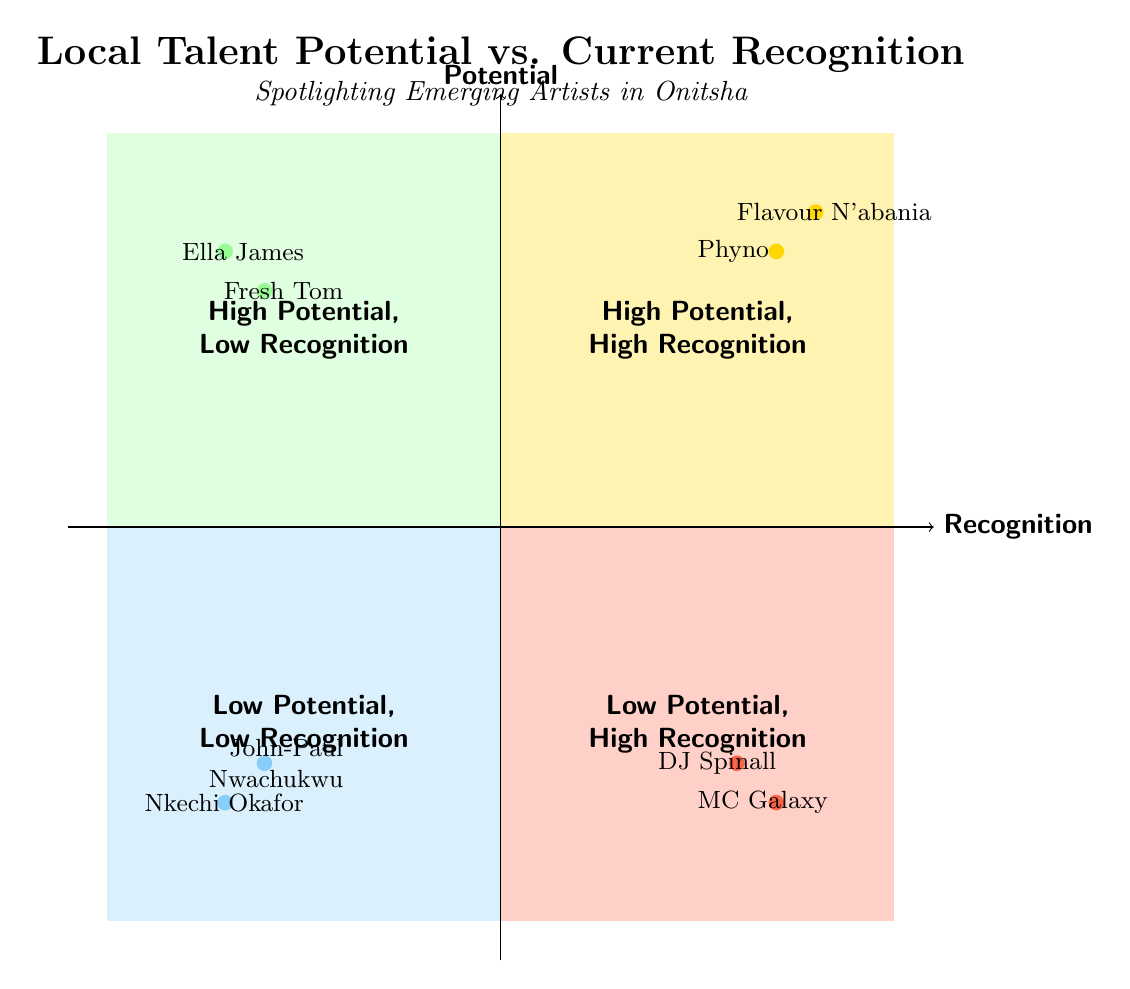What are the names of the artists in the High Potential, High Recognition quadrant? In the diagram, the High Potential, High Recognition quadrant lists the names of two artists: Flavour N'abania and Phyno. These names are located in the top right quadrant, which signifies both high potential and high recognition.
Answer: Flavour N'abania, Phyno How many artists are listed in the Low Potential, Low Recognition quadrant? The Low Potential, Low Recognition quadrant contains two artists: John-Paul Nwachukwu and Nkechi Okafor. By counting the elements in this quadrant, we find there are a total of two artists.
Answer: 2 Which artist is recognized within church circles in the High Potential, Low Recognition quadrant? In the High Potential, Low Recognition quadrant, Ella James is described as a talented gospel singer currently recognized within church circles. This information is found in the upper left quadrant where she is listed as one of the emerging artists.
Answer: Ella James What is the main criticism faced by MC Galaxy in the Low Potential, High Recognition quadrant? The diagram states that MC Galaxy faces criticism for a lack of musical diversity. This detail indicates the reason for his classification in the Low Potential, High Recognition quadrant.
Answer: Lack of musical diversity Which quadrant contains artists recognized for their unique styles? The High Potential, Low Recognition quadrant contains Fresh Tom, who is known for deep lyrics in hip hop, while the High Potential, High Recognition quadrant contains Phyno, known for his unique rap style. Therefore, both quadrants include artists celebrated for their unique styles.
Answer: High Potential, Low Recognition and High Potential, High Recognition How many artists are there in both High Potential quadrants? By checking the diagram, we see that there are four artists in the High Potential quadrants: two in the High Potential, High Recognition quadrant (Flavour N'abania and Phyno) and two in the High Potential, Low Recognition quadrant (Fresh Tom and Ella James). Thus, a sum of four artists can be identified.
Answer: 4 